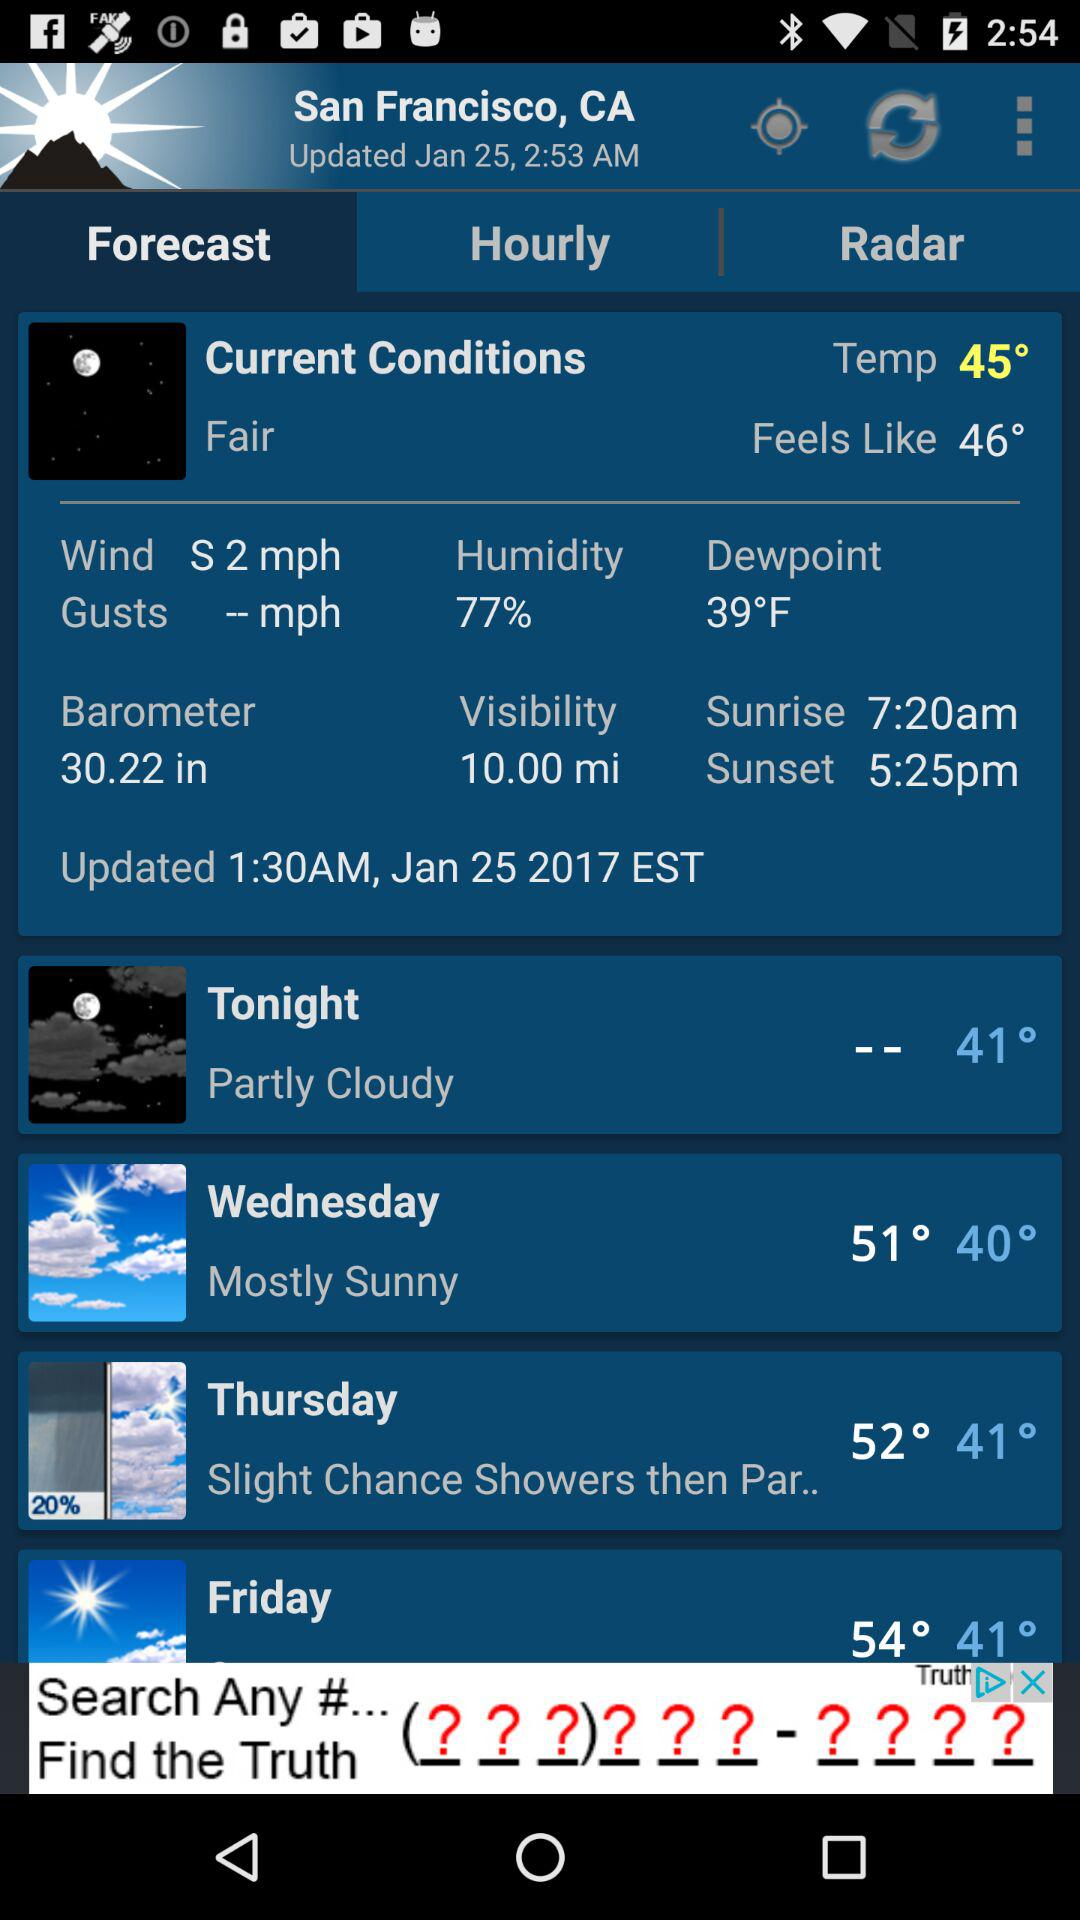When was the weather forecast updated? The weather forecast was updated at 1:30 AM on January 25, 2017 EST. 